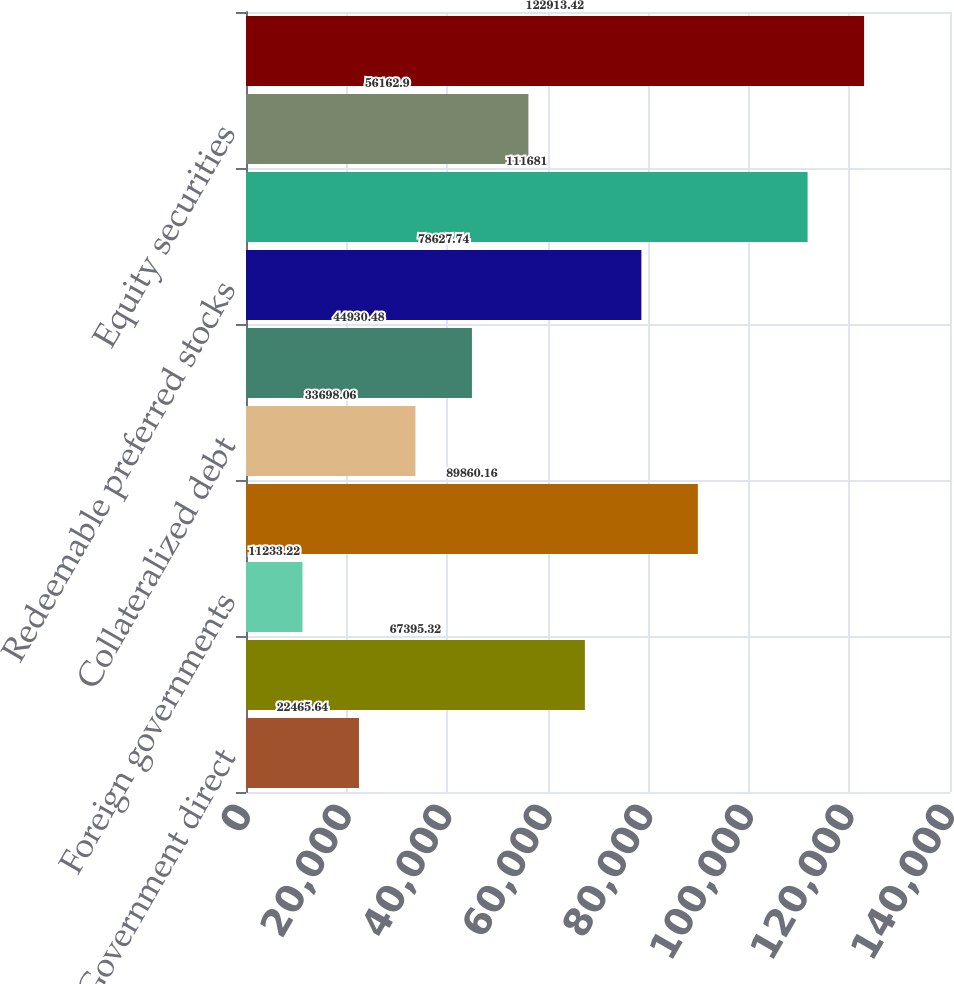Convert chart. <chart><loc_0><loc_0><loc_500><loc_500><bar_chart><fcel>US Government direct<fcel>States municipalities and<fcel>Foreign governments<fcel>Corporates<fcel>Collateralized debt<fcel>Other asset-backed securities<fcel>Redeemable preferred stocks<fcel>Total fixed maturities<fcel>Equity securities<fcel>Total fixed maturities and<nl><fcel>22465.6<fcel>67395.3<fcel>11233.2<fcel>89860.2<fcel>33698.1<fcel>44930.5<fcel>78627.7<fcel>111681<fcel>56162.9<fcel>122913<nl></chart> 